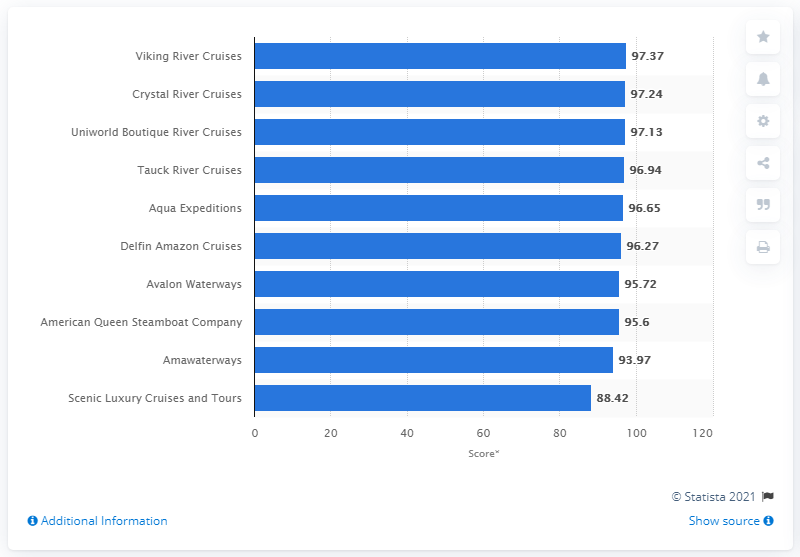Highlight a few significant elements in this photo. The rating of Viking River Cruises as selected by readers of Cond Nast Traveler was 97.37. 